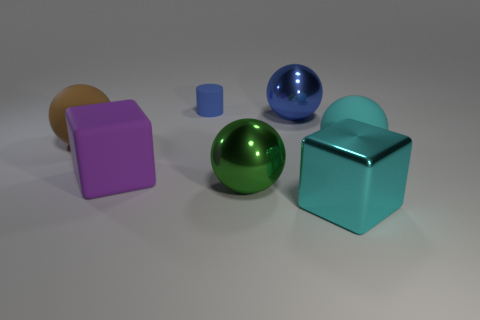Subtract all large cyan rubber spheres. How many spheres are left? 3 Subtract all cyan spheres. How many spheres are left? 3 Add 2 green matte blocks. How many objects exist? 9 Subtract all yellow balls. Subtract all cyan cylinders. How many balls are left? 4 Subtract 0 blue cubes. How many objects are left? 7 Subtract all cylinders. How many objects are left? 6 Subtract all small matte cubes. Subtract all big metallic objects. How many objects are left? 4 Add 4 green metal balls. How many green metal balls are left? 5 Add 6 metal cubes. How many metal cubes exist? 7 